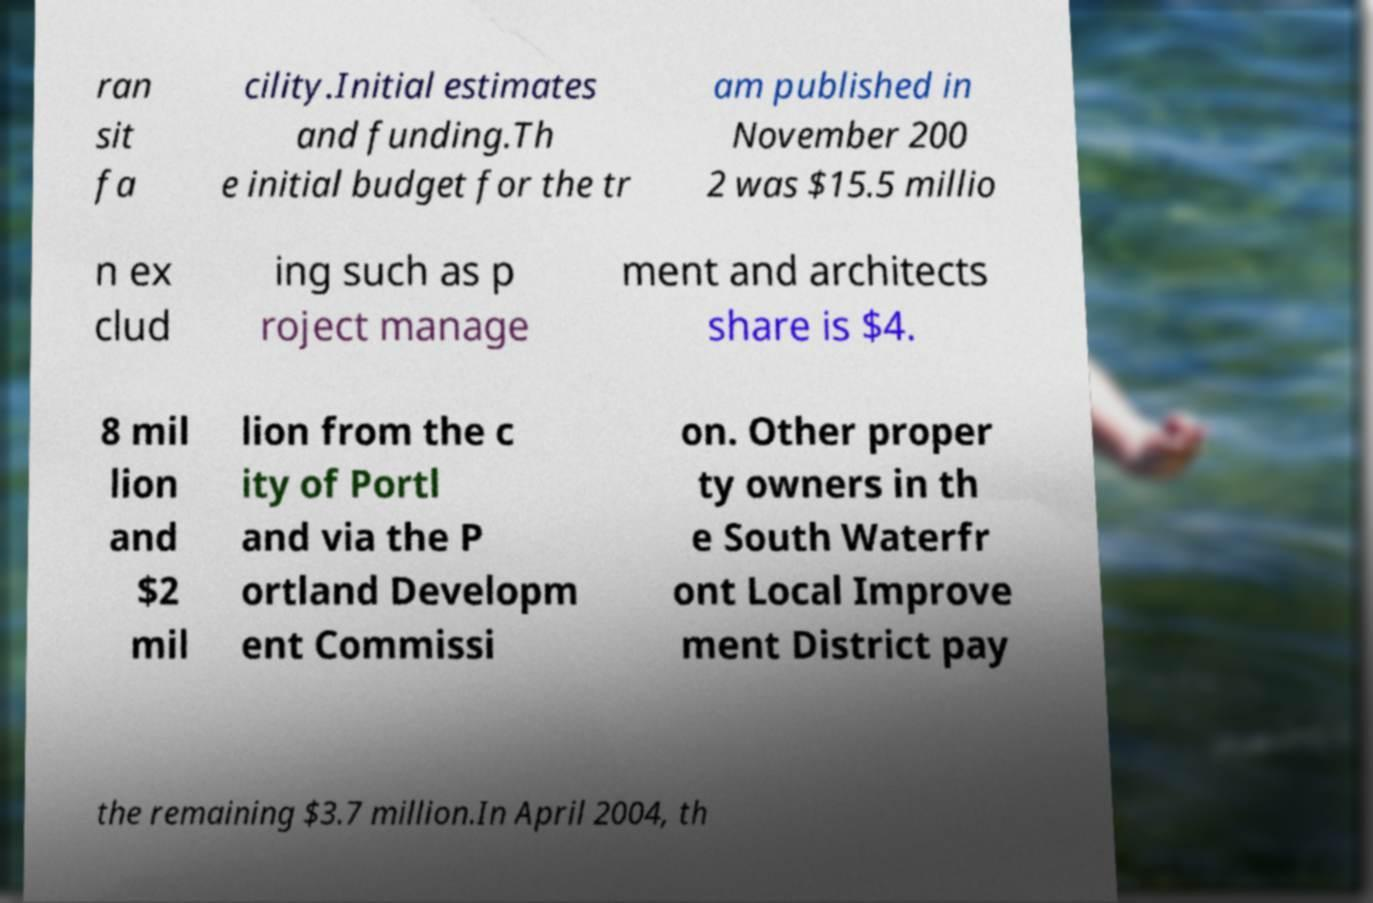Could you extract and type out the text from this image? ran sit fa cility.Initial estimates and funding.Th e initial budget for the tr am published in November 200 2 was $15.5 millio n ex clud ing such as p roject manage ment and architects share is $4. 8 mil lion and $2 mil lion from the c ity of Portl and via the P ortland Developm ent Commissi on. Other proper ty owners in th e South Waterfr ont Local Improve ment District pay the remaining $3.7 million.In April 2004, th 